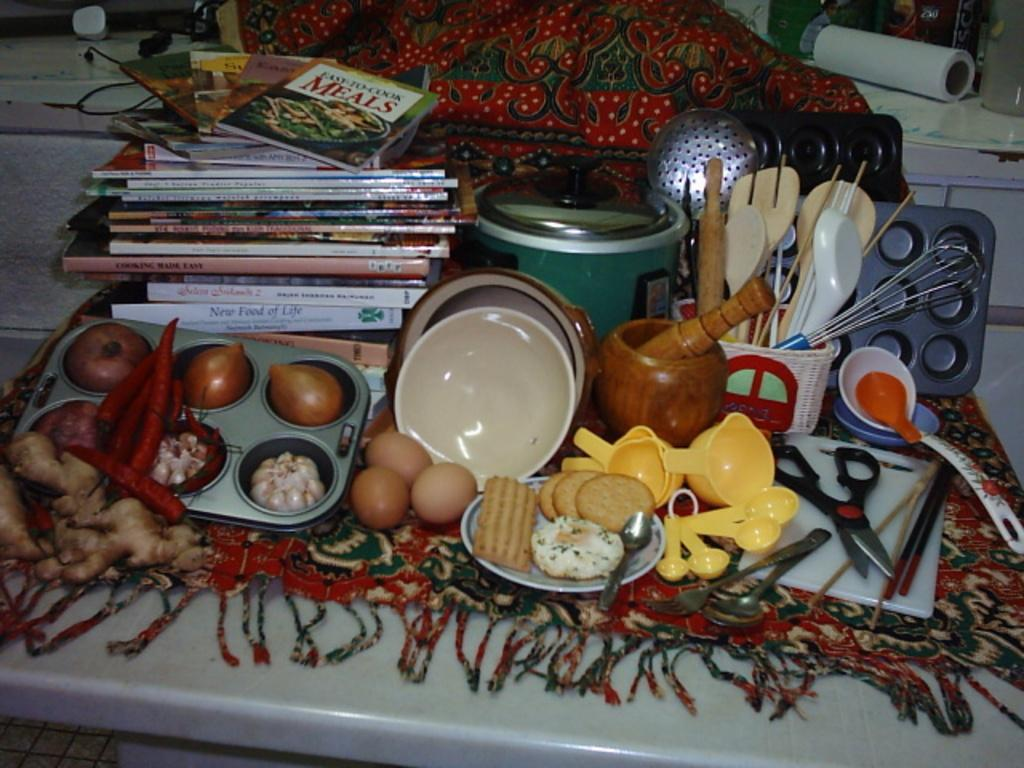Provide a one-sentence caption for the provided image. Easy to Cook Meals is the title of the book on the top of the pile. 